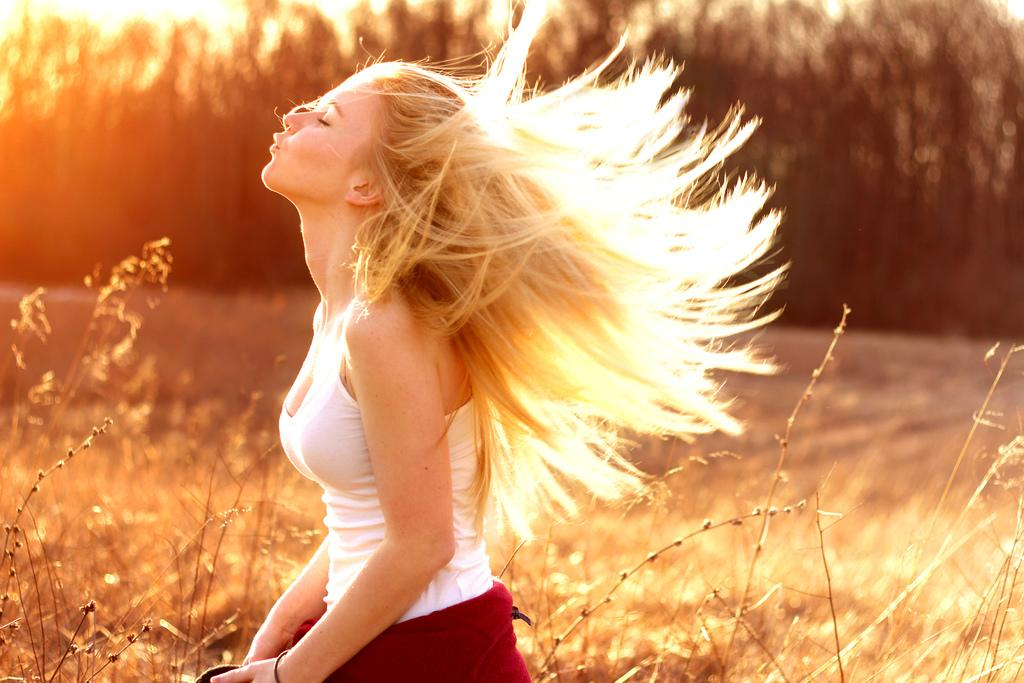Who or what is the main subject in the image? There is a person in the image. What is the person wearing? The person is wearing a white and red color dress. What is the person doing in the image? The person is crouching down. What can be seen in the background of the image? There are plants, trees, and the sky visible in the background of the image. What type of organization is the person visiting in the image? There is no organization present in the image; it features a person crouching down in a setting with plants, trees, and a sunny sky. Can you tell me if the person is getting a haircut in the image? There is no indication in the image that the person is getting a haircut. 